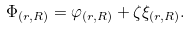Convert formula to latex. <formula><loc_0><loc_0><loc_500><loc_500>\Phi _ { \left ( r , R \right ) } = \varphi _ { \left ( r , R \right ) } + \zeta \xi _ { \left ( r , R \right ) } .</formula> 